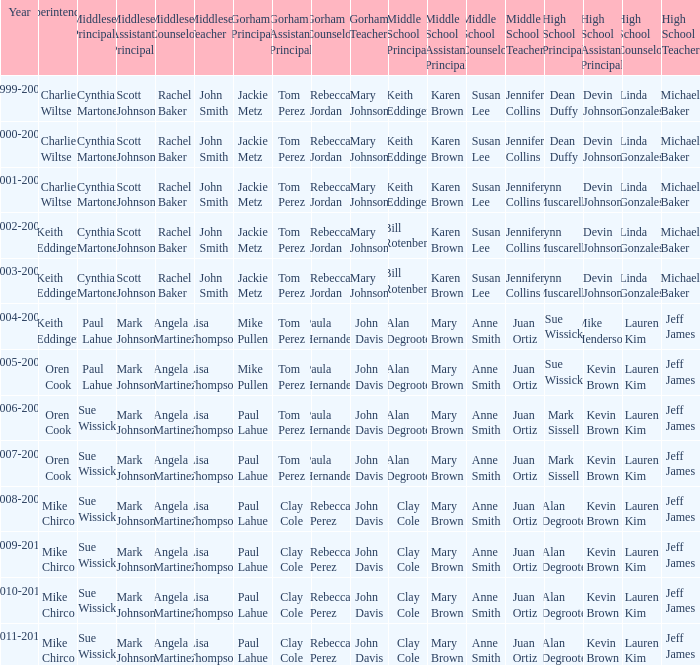How many years was lynn muscarella the high school principal and charlie wiltse the superintendent? 1.0. 